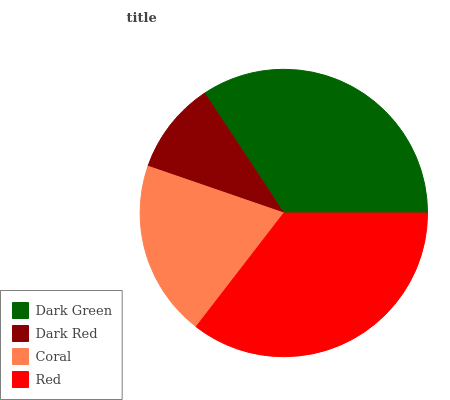Is Dark Red the minimum?
Answer yes or no. Yes. Is Red the maximum?
Answer yes or no. Yes. Is Coral the minimum?
Answer yes or no. No. Is Coral the maximum?
Answer yes or no. No. Is Coral greater than Dark Red?
Answer yes or no. Yes. Is Dark Red less than Coral?
Answer yes or no. Yes. Is Dark Red greater than Coral?
Answer yes or no. No. Is Coral less than Dark Red?
Answer yes or no. No. Is Dark Green the high median?
Answer yes or no. Yes. Is Coral the low median?
Answer yes or no. Yes. Is Coral the high median?
Answer yes or no. No. Is Red the low median?
Answer yes or no. No. 